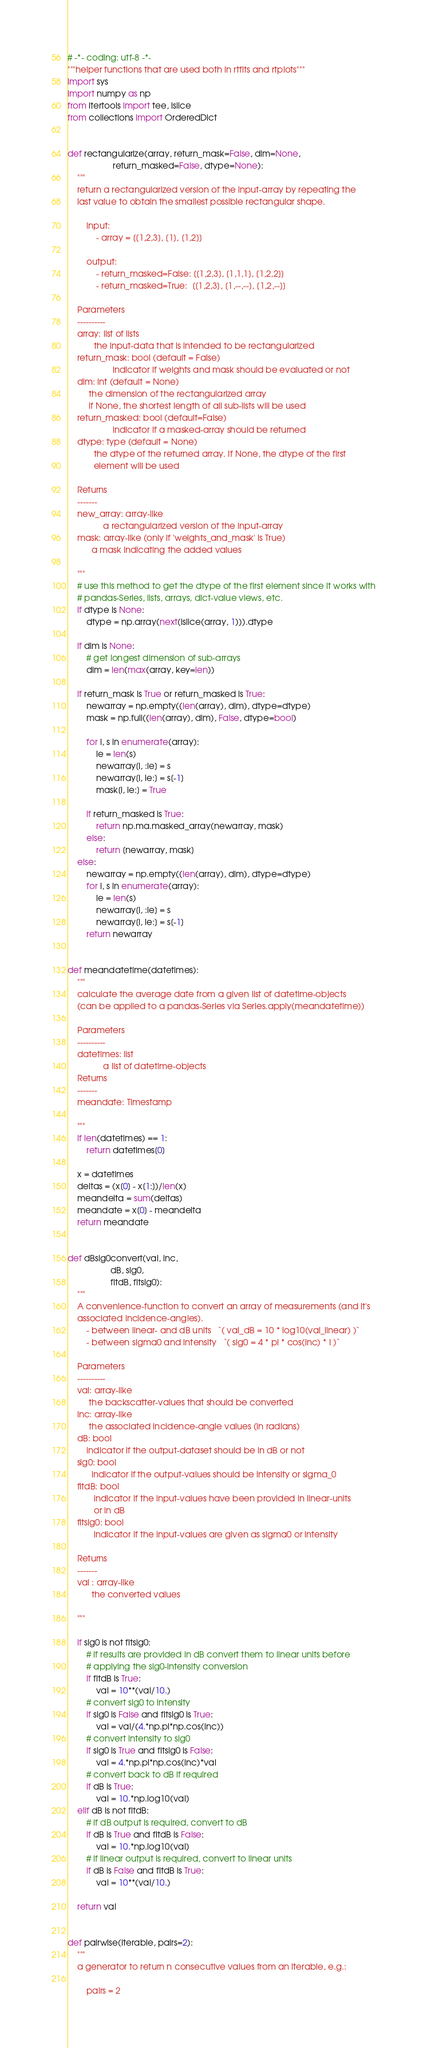<code> <loc_0><loc_0><loc_500><loc_500><_Python_># -*- coding: utf-8 -*-
"""helper functions that are used both in rtfits and rtplots"""
import sys
import numpy as np
from itertools import tee, islice
from collections import OrderedDict


def rectangularize(array, return_mask=False, dim=None,
                   return_masked=False, dtype=None):
    """
    return a rectangularized version of the input-array by repeating the
    last value to obtain the smallest possible rectangular shape.

        input:
            - array = [[1,2,3], [1], [1,2]]

        output:
            - return_masked=False: [[1,2,3], [1,1,1], [1,2,2]]
            - return_masked=True:  [[1,2,3], [1,--,--], [1,2,--]]

    Parameters
    ----------
    array: list of lists
           the input-data that is intended to be rectangularized
    return_mask: bool (default = False)
                   indicator if weights and mask should be evaluated or not
    dim: int (default = None)
         the dimension of the rectangularized array
         if None, the shortest length of all sub-lists will be used
    return_masked: bool (default=False)
                   indicator if a masked-array should be returned
    dtype: type (default = None)
           the dtype of the returned array. If None, the dtype of the first
           element will be used

    Returns
    -------
    new_array: array-like
               a rectangularized version of the input-array
    mask: array-like (only if 'weights_and_mask' is True)
          a mask indicating the added values

    """
    # use this method to get the dtype of the first element since it works with
    # pandas-Series, lists, arrays, dict-value views, etc.
    if dtype is None:
        dtype = np.array(next(islice(array, 1))).dtype

    if dim is None:
        # get longest dimension of sub-arrays
        dim = len(max(array, key=len))

    if return_mask is True or return_masked is True:
        newarray = np.empty((len(array), dim), dtype=dtype)
        mask = np.full((len(array), dim), False, dtype=bool)

        for i, s in enumerate(array):
            le = len(s)
            newarray[i, :le] = s
            newarray[i, le:] = s[-1]
            mask[i, le:] = True

        if return_masked is True:
            return np.ma.masked_array(newarray, mask)
        else:
            return [newarray, mask]
    else:
        newarray = np.empty((len(array), dim), dtype=dtype)
        for i, s in enumerate(array):
            le = len(s)
            newarray[i, :le] = s
            newarray[i, le:] = s[-1]
        return newarray


def meandatetime(datetimes):
    """
    calculate the average date from a given list of datetime-objects
    (can be applied to a pandas-Series via Series.apply(meandatetime))

    Parameters
    ----------
    datetimes: list
               a list of datetime-objects
    Returns
    -------
    meandate: Timestamp

    """
    if len(datetimes) == 1:
        return datetimes[0]

    x = datetimes
    deltas = (x[0] - x[1:])/len(x)
    meandelta = sum(deltas)
    meandate = x[0] - meandelta
    return meandate


def dBsig0convert(val, inc,
                  dB, sig0,
                  fitdB, fitsig0):
    """
    A convenience-function to convert an array of measurements (and it's
    associated incidence-angles).
        - between linear- and dB units   `( val_dB = 10 * log10(val_linear) )`
        - between sigma0 and intensity   `( sig0 = 4 * pi * cos(inc) * I )`

    Parameters
    ----------
    val: array-like
         the backscatter-values that should be converted
    inc: array-like
         the associated incidence-angle values (in radians)
    dB: bool
        indicator if the output-dataset should be in dB or not
    sig0: bool
          indicator if the output-values should be intensity or sigma_0
    fitdB: bool
           indicator if the input-values have been provided in linear-units
           or in dB
    fitsig0: bool
           indicator if the input-values are given as sigma0 or intensity

    Returns
    -------
    val : array-like
          the converted values

    """

    if sig0 is not fitsig0:
        # if results are provided in dB convert them to linear units before
        # applying the sig0-intensity conversion
        if fitdB is True:
            val = 10**(val/10.)
        # convert sig0 to intensity
        if sig0 is False and fitsig0 is True:
            val = val/(4.*np.pi*np.cos(inc))
        # convert intensity to sig0
        if sig0 is True and fitsig0 is False:
            val = 4.*np.pi*np.cos(inc)*val
        # convert back to dB if required
        if dB is True:
            val = 10.*np.log10(val)
    elif dB is not fitdB:
        # if dB output is required, convert to dB
        if dB is True and fitdB is False:
            val = 10.*np.log10(val)
        # if linear output is required, convert to linear units
        if dB is False and fitdB is True:
            val = 10**(val/10.)

    return val


def pairwise(iterable, pairs=2):
    """
    a generator to return n consecutive values from an iterable, e.g.:

        pairs = 2</code> 